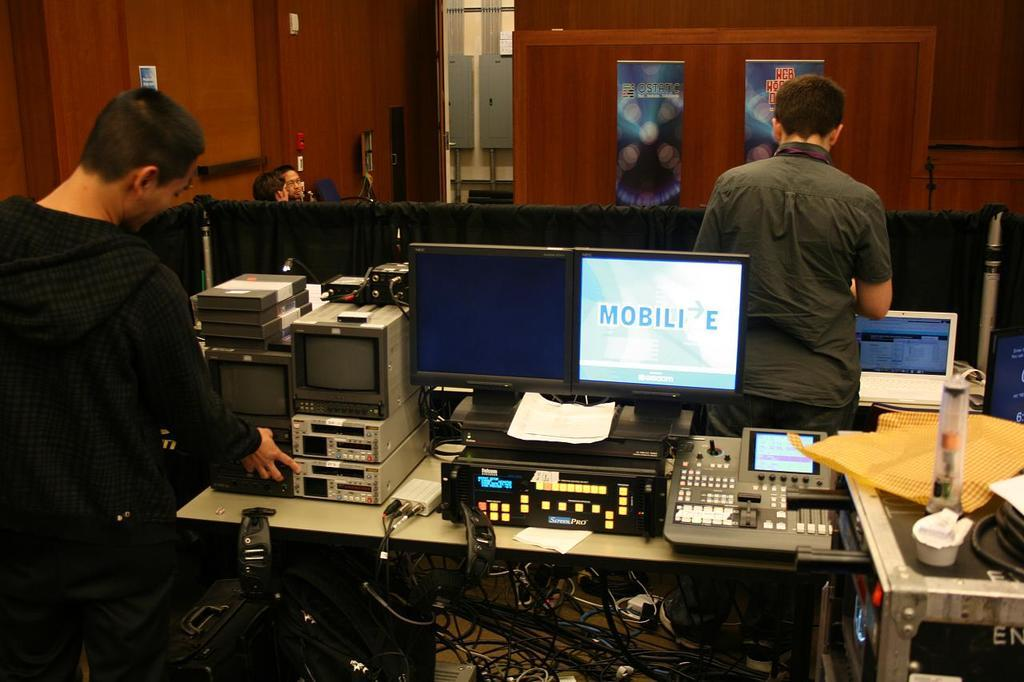<image>
Provide a brief description of the given image. A computer on a desk, the word Mobili is visible. 